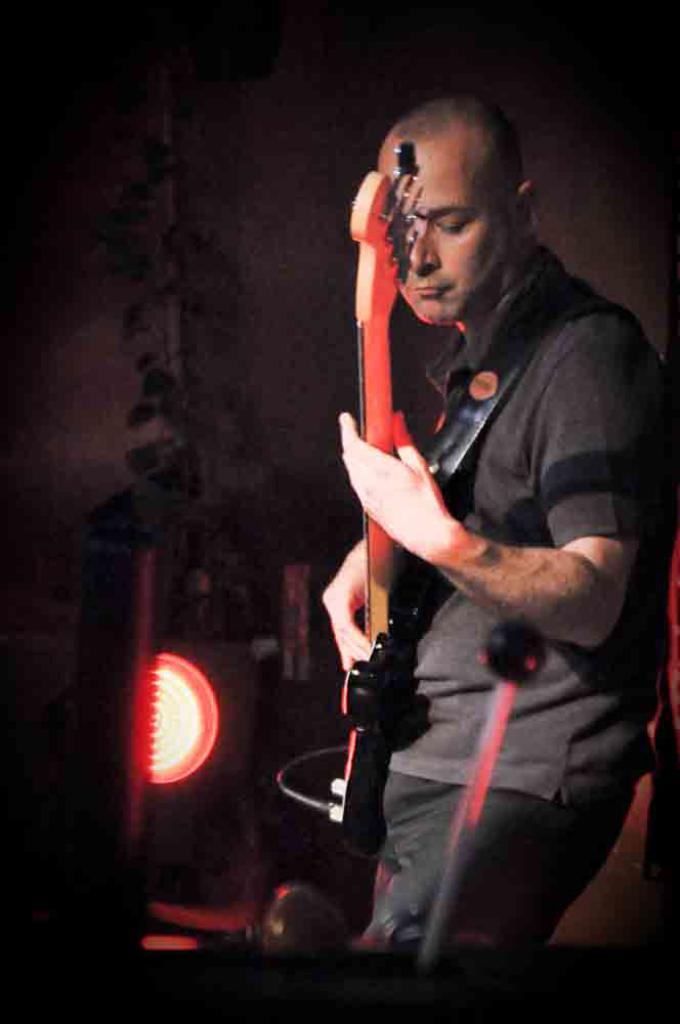What is the man in the image doing? The man is playing a guitar in the image. Can you describe the background of the image? There is a plant and a light in the background of the image. What is the man's opinion on the tooth in the image? There is no tooth present in the image, so it is not possible to determine the man's opinion on it. 